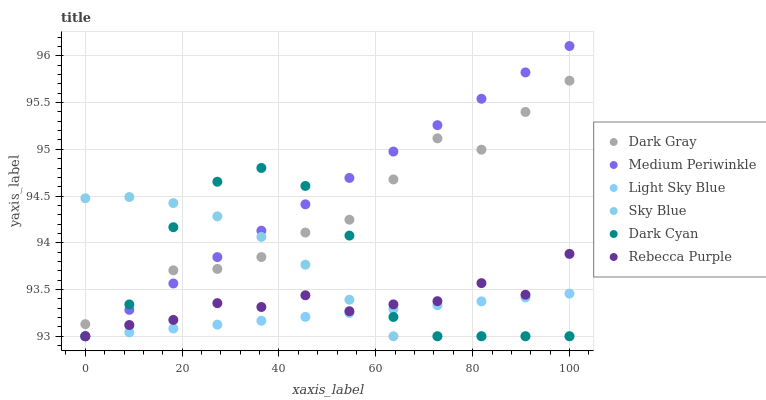Does Light Sky Blue have the minimum area under the curve?
Answer yes or no. Yes. Does Medium Periwinkle have the maximum area under the curve?
Answer yes or no. Yes. Does Dark Gray have the minimum area under the curve?
Answer yes or no. No. Does Dark Gray have the maximum area under the curve?
Answer yes or no. No. Is Light Sky Blue the smoothest?
Answer yes or no. Yes. Is Dark Cyan the roughest?
Answer yes or no. Yes. Is Dark Gray the smoothest?
Answer yes or no. No. Is Dark Gray the roughest?
Answer yes or no. No. Does Medium Periwinkle have the lowest value?
Answer yes or no. Yes. Does Dark Gray have the lowest value?
Answer yes or no. No. Does Medium Periwinkle have the highest value?
Answer yes or no. Yes. Does Dark Gray have the highest value?
Answer yes or no. No. Is Light Sky Blue less than Dark Gray?
Answer yes or no. Yes. Is Dark Gray greater than Light Sky Blue?
Answer yes or no. Yes. Does Rebecca Purple intersect Light Sky Blue?
Answer yes or no. Yes. Is Rebecca Purple less than Light Sky Blue?
Answer yes or no. No. Is Rebecca Purple greater than Light Sky Blue?
Answer yes or no. No. Does Light Sky Blue intersect Dark Gray?
Answer yes or no. No. 